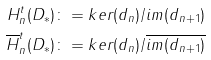Convert formula to latex. <formula><loc_0><loc_0><loc_500><loc_500>H _ { n } ^ { t } ( D _ { * } ) \colon = k e r ( d _ { n } ) / i m ( d _ { n + 1 } ) \\ \overline { H } _ { n } ^ { t } ( D _ { * } ) \colon = k e r ( d _ { n } ) / \overline { i m ( d _ { n + 1 } ) }</formula> 